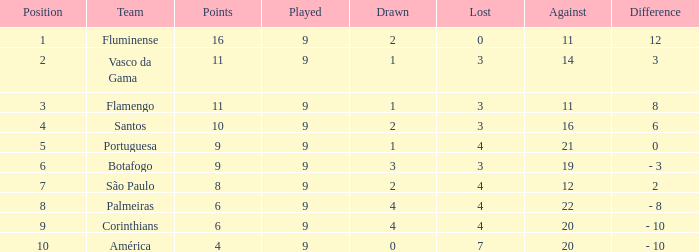What is the greatest point that has a 1 position and a negative lost value? None. 